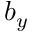Convert formula to latex. <formula><loc_0><loc_0><loc_500><loc_500>b _ { y }</formula> 